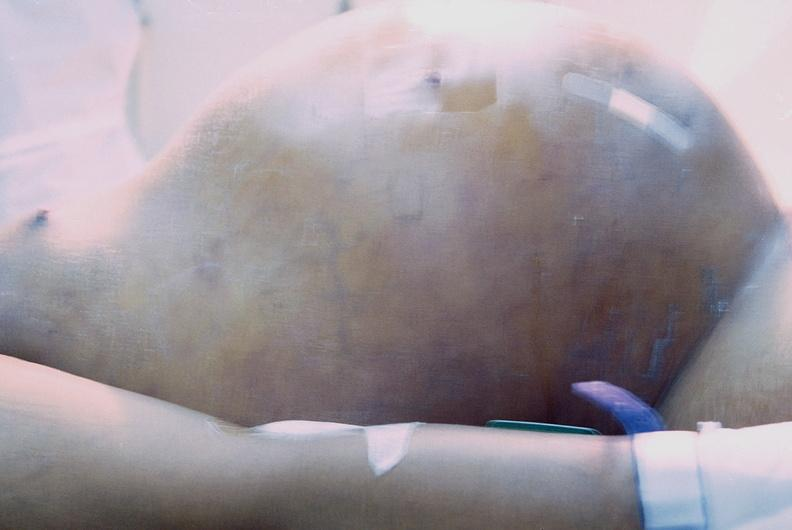s abdomen present?
Answer the question using a single word or phrase. Yes 